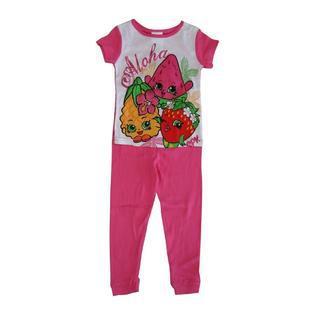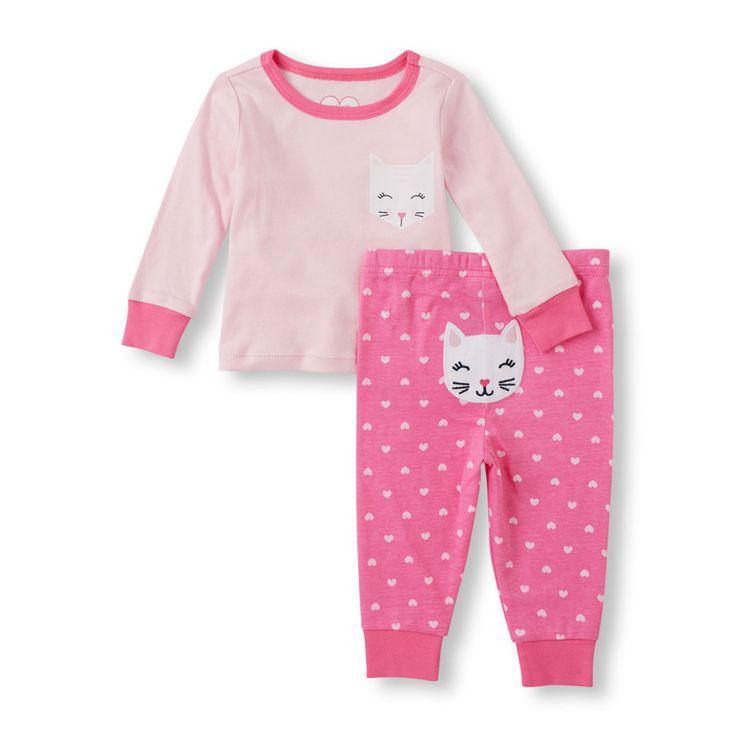The first image is the image on the left, the second image is the image on the right. Evaluate the accuracy of this statement regarding the images: "a pair of pajamas has short sleeves and long pants". Is it true? Answer yes or no. Yes. The first image is the image on the left, the second image is the image on the right. Considering the images on both sides, is "There is one pair of shorts and one pair of pants." valid? Answer yes or no. No. 